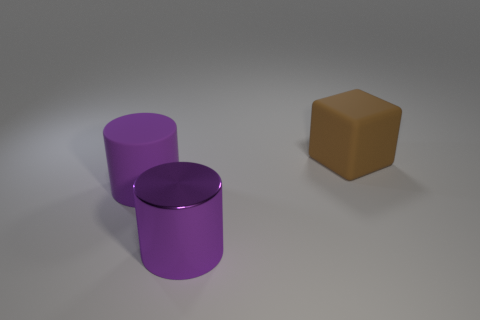Subtract all gray cylinders. Subtract all cyan spheres. How many cylinders are left? 2 Add 2 purple cylinders. How many objects exist? 5 Subtract all cylinders. How many objects are left? 1 Subtract all small blue metallic cylinders. Subtract all shiny cylinders. How many objects are left? 2 Add 2 large purple metallic objects. How many large purple metallic objects are left? 3 Add 2 brown rubber cubes. How many brown rubber cubes exist? 3 Subtract 0 cyan balls. How many objects are left? 3 